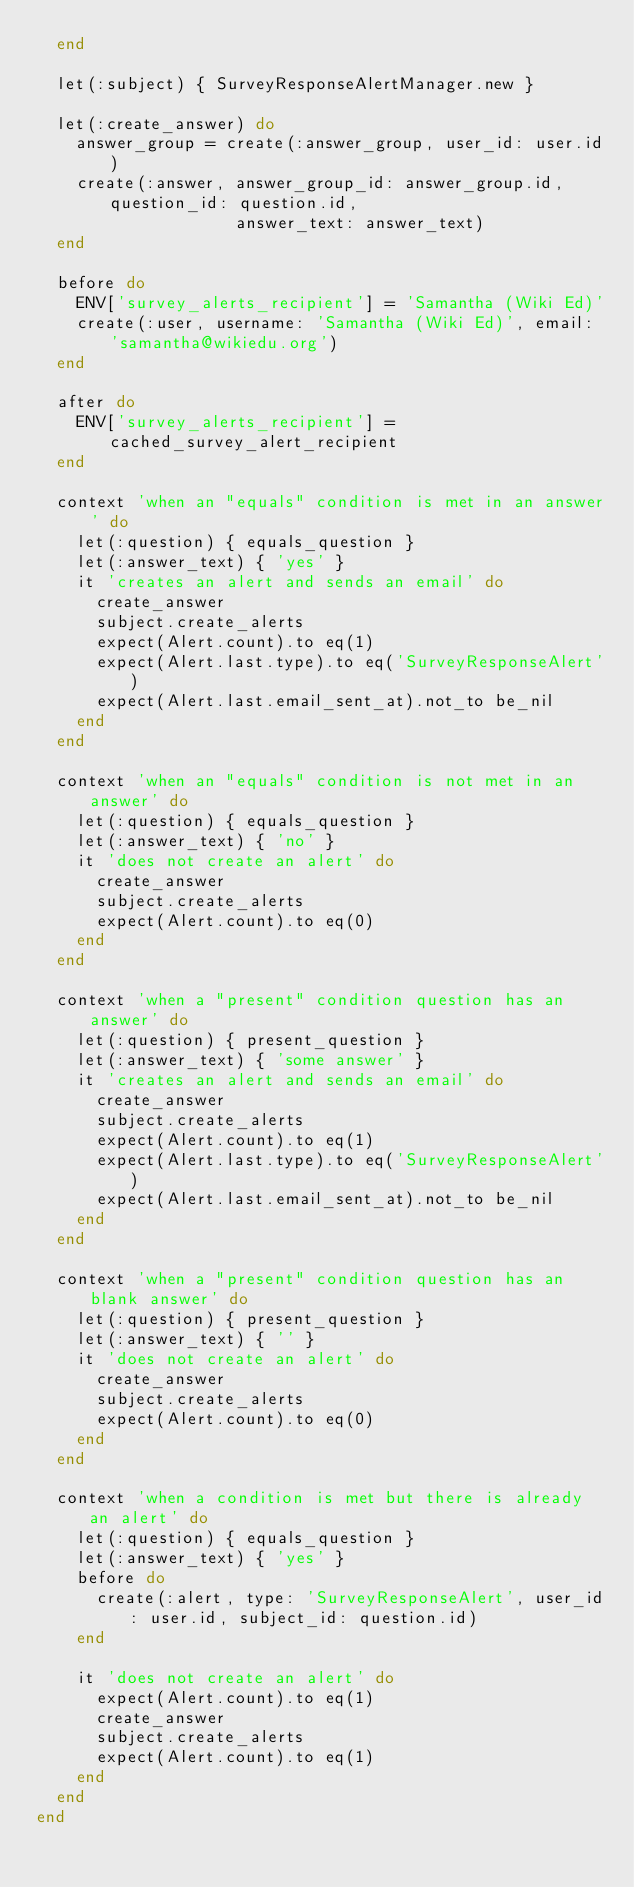Convert code to text. <code><loc_0><loc_0><loc_500><loc_500><_Ruby_>  end

  let(:subject) { SurveyResponseAlertManager.new }

  let(:create_answer) do
    answer_group = create(:answer_group, user_id: user.id)
    create(:answer, answer_group_id: answer_group.id, question_id: question.id,
                    answer_text: answer_text)
  end

  before do
    ENV['survey_alerts_recipient'] = 'Samantha (Wiki Ed)'
    create(:user, username: 'Samantha (Wiki Ed)', email: 'samantha@wikiedu.org')
  end

  after do
    ENV['survey_alerts_recipient'] = cached_survey_alert_recipient
  end

  context 'when an "equals" condition is met in an answer' do
    let(:question) { equals_question }
    let(:answer_text) { 'yes' }
    it 'creates an alert and sends an email' do
      create_answer
      subject.create_alerts
      expect(Alert.count).to eq(1)
      expect(Alert.last.type).to eq('SurveyResponseAlert')
      expect(Alert.last.email_sent_at).not_to be_nil
    end
  end

  context 'when an "equals" condition is not met in an answer' do
    let(:question) { equals_question }
    let(:answer_text) { 'no' }
    it 'does not create an alert' do
      create_answer
      subject.create_alerts
      expect(Alert.count).to eq(0)
    end
  end

  context 'when a "present" condition question has an answer' do
    let(:question) { present_question }
    let(:answer_text) { 'some answer' }
    it 'creates an alert and sends an email' do
      create_answer
      subject.create_alerts
      expect(Alert.count).to eq(1)
      expect(Alert.last.type).to eq('SurveyResponseAlert')
      expect(Alert.last.email_sent_at).not_to be_nil
    end
  end

  context 'when a "present" condition question has an blank answer' do
    let(:question) { present_question }
    let(:answer_text) { '' }
    it 'does not create an alert' do
      create_answer
      subject.create_alerts
      expect(Alert.count).to eq(0)
    end
  end

  context 'when a condition is met but there is already an alert' do
    let(:question) { equals_question }
    let(:answer_text) { 'yes' }
    before do
      create(:alert, type: 'SurveyResponseAlert', user_id: user.id, subject_id: question.id)
    end

    it 'does not create an alert' do
      expect(Alert.count).to eq(1)
      create_answer
      subject.create_alerts
      expect(Alert.count).to eq(1)
    end
  end
end
</code> 